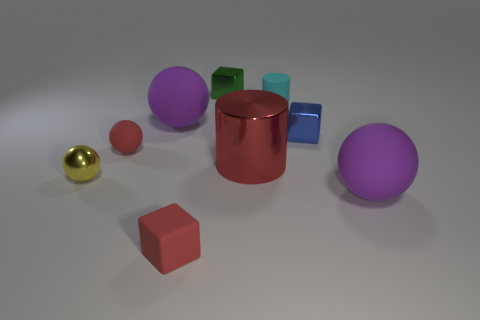Subtract all blue spheres. Subtract all yellow blocks. How many spheres are left? 4 Subtract all blocks. How many objects are left? 6 Subtract 1 purple spheres. How many objects are left? 8 Subtract all purple spheres. Subtract all tiny cyan objects. How many objects are left? 6 Add 5 big shiny cylinders. How many big shiny cylinders are left? 6 Add 9 purple metallic things. How many purple metallic things exist? 9 